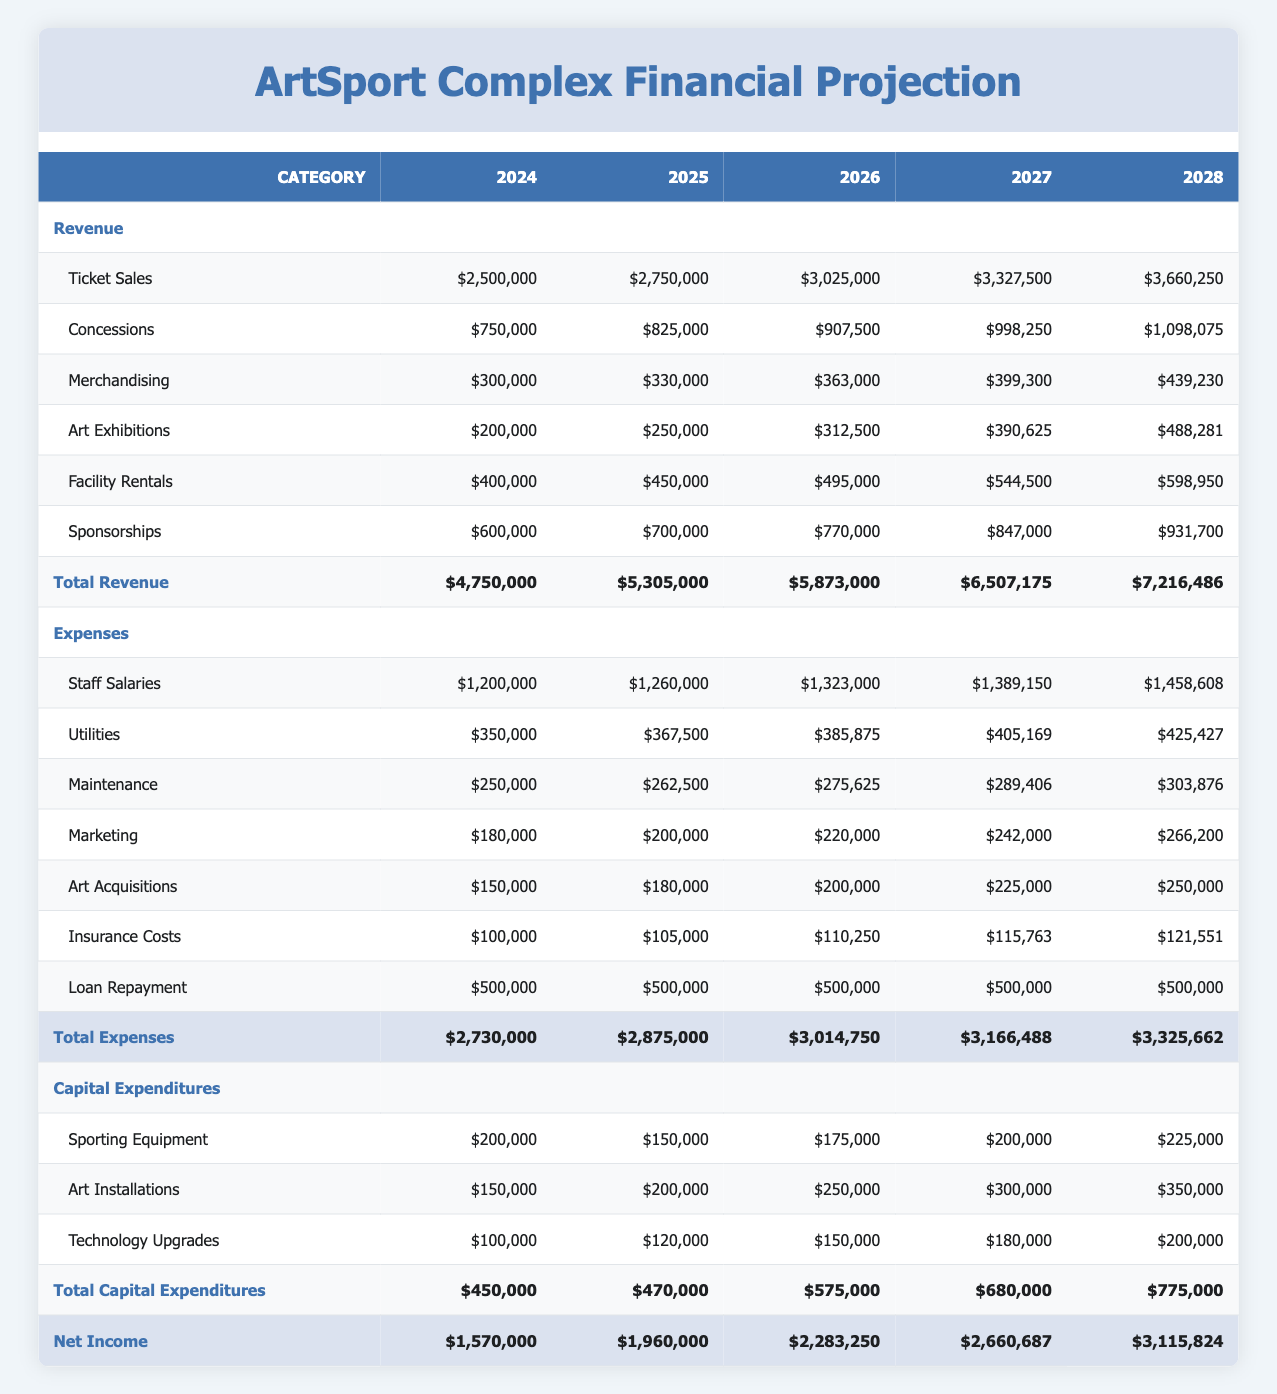What is the total revenue for the year 2026? The total revenue for the year 2026 is listed directly under the "Total Revenue" row for that year, which shows 5,873,000.
Answer: 5,873,000 What was the percentage increase in total revenue from 2024 to 2025? The total revenue in 2024 was 4,750,000 and in 2025 it was 5,305,000. The increase is 5,305,000 - 4,750,000 = 555,000. To find the percentage increase, divide 555,000 by 4,750,000 and multiply by 100, resulting in approximately 11.68%.
Answer: 11.68% Is the total expenses for the year 2028 greater than the total expenses for 2026? By comparing the "Total Expenses" row values, the total expenses for 2028 are 3,325,662, and for 2026 are 3,014,750. Since 3,325,662 is greater than 3,014,750, the answer is yes.
Answer: Yes What is the net income for the year 2027? The net income for the year 2027 is directly listed under the "Net Income" row for that year, showing 2,660,687.
Answer: 2,660,687 What is the average amount spent on art acquisitions over the five years? The amounts spent on art acquisitions from 2024 to 2028 are 150,000, 180,000, 200,000, 225,000, and 250,000. To find the average, add these amounts together (150,000 + 180,000 + 200,000 + 225,000 + 250,000 = 1,005,000) and then divide by 5, leading to an average of 201,000.
Answer: 201,000 How much revenue was generated from sponsorships in 2025? The revenue from sponsorships for 2025 is directly shown in the "Sponsorships" row for that year, which is 700,000.
Answer: 700,000 Which year had the highest total capital expenditures? To find the year with the highest total capital expenditures, compare the "Total Capital Expenditures" values: 450,000 (2024), 470,000 (2025), 575,000 (2026), 680,000 (2027), and 775,000 (2028). The highest value is 775,000 for the year 2028.
Answer: 2028 What is the difference in total revenue between 2026 and 2028? The total revenue for 2026 is 5,873,000 and for 2028 it is 7,216,486. The difference is calculated by subtracting: 7,216,486 - 5,873,000 = 1,343,486.
Answer: 1,343,486 